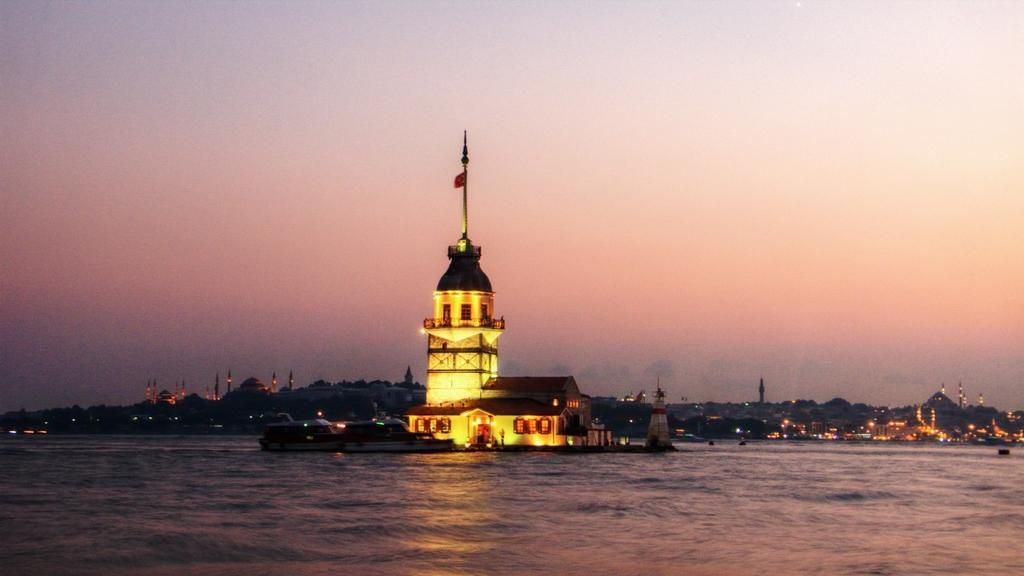What is the main structure in the image? There is a lighthouse in the image. Where is the lighthouse located? The lighthouse is in the middle of the sea. What can be seen in the background of the image? There are buildings on the land in the background of the image. What is visible above the sea and buildings? The sky is visible in the image. Which actor is performing on the lighthouse in the image? There are no actors or performances present in the image; it features a lighthouse in the middle of the sea. 